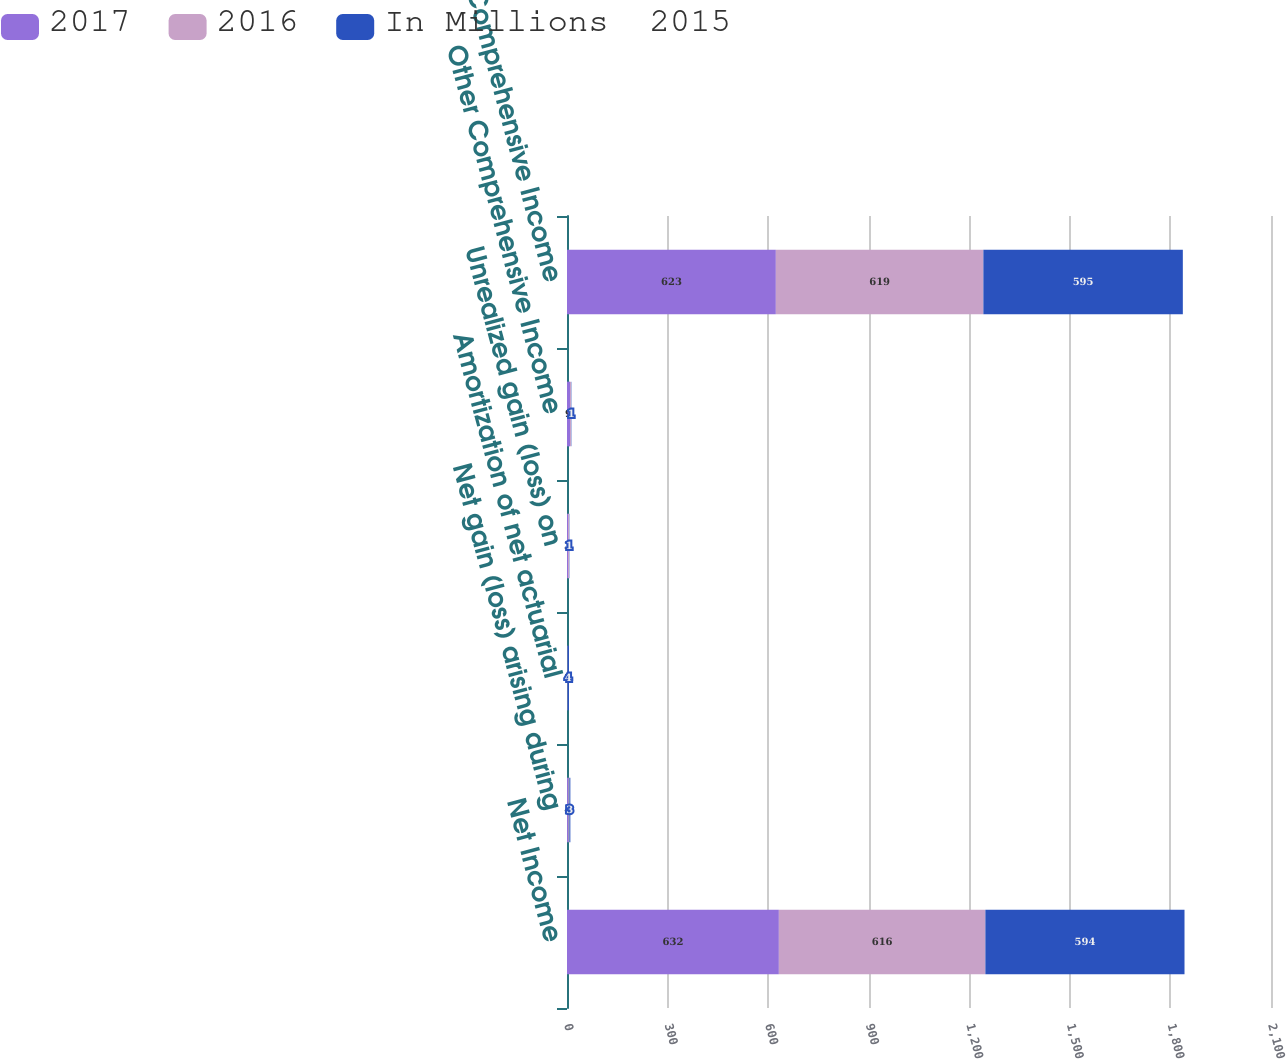Convert chart to OTSL. <chart><loc_0><loc_0><loc_500><loc_500><stacked_bar_chart><ecel><fcel>Net Income<fcel>Net gain (loss) arising during<fcel>Amortization of net actuarial<fcel>Unrealized gain (loss) on<fcel>Other Comprehensive Income<fcel>Comprehensive Income<nl><fcel>2017<fcel>632<fcel>4<fcel>1<fcel>3<fcel>9<fcel>623<nl><fcel>2016<fcel>616<fcel>3<fcel>1<fcel>3<fcel>3<fcel>619<nl><fcel>In Millions  2015<fcel>594<fcel>3<fcel>4<fcel>1<fcel>1<fcel>595<nl></chart> 